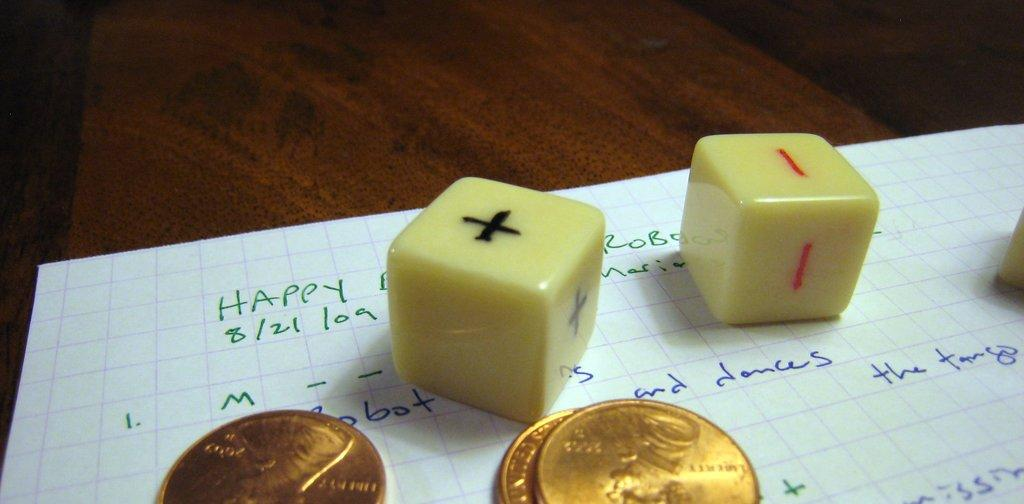<image>
Provide a brief description of the given image. Three pennies on a paper along with two dice one which has plus marks on it and one which has minus marks. 